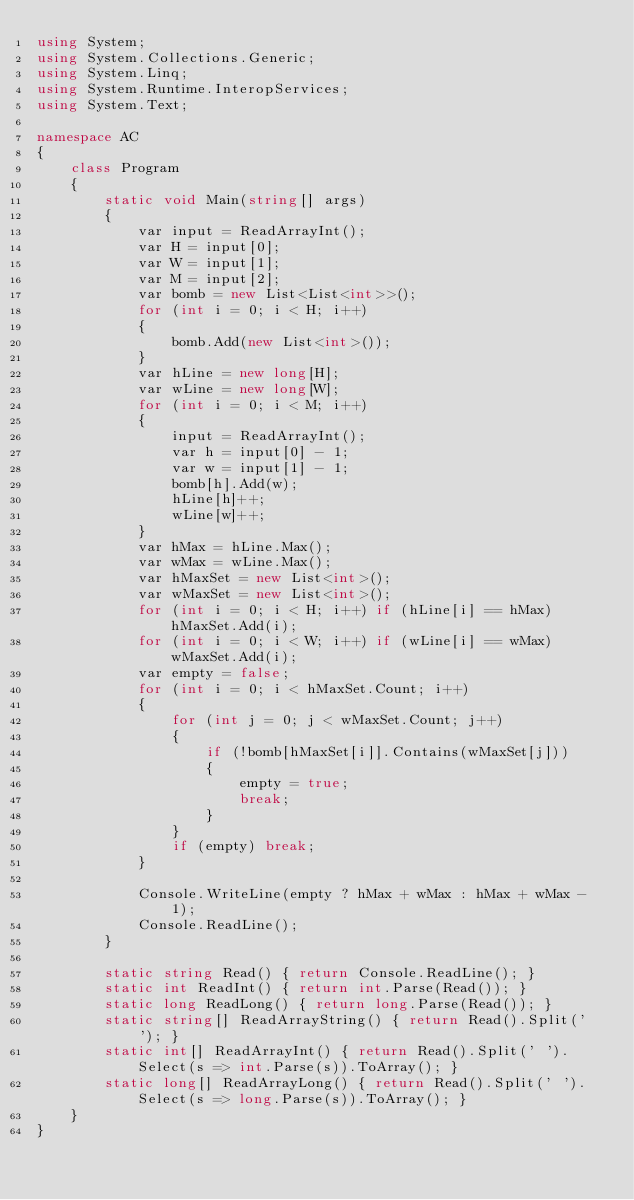<code> <loc_0><loc_0><loc_500><loc_500><_C#_>using System;
using System.Collections.Generic;
using System.Linq;
using System.Runtime.InteropServices;
using System.Text;

namespace AC
{
    class Program
    {
        static void Main(string[] args)
        {
            var input = ReadArrayInt();
            var H = input[0];
            var W = input[1];
            var M = input[2];
            var bomb = new List<List<int>>();
            for (int i = 0; i < H; i++)
            {
                bomb.Add(new List<int>());
            }
            var hLine = new long[H];
            var wLine = new long[W];
            for (int i = 0; i < M; i++)
            {
                input = ReadArrayInt();
                var h = input[0] - 1;
                var w = input[1] - 1;
                bomb[h].Add(w);
                hLine[h]++;
                wLine[w]++;
            }
            var hMax = hLine.Max();
            var wMax = wLine.Max();
            var hMaxSet = new List<int>();
            var wMaxSet = new List<int>();
            for (int i = 0; i < H; i++) if (hLine[i] == hMax) hMaxSet.Add(i);
            for (int i = 0; i < W; i++) if (wLine[i] == wMax) wMaxSet.Add(i);
            var empty = false;
            for (int i = 0; i < hMaxSet.Count; i++)
            {
                for (int j = 0; j < wMaxSet.Count; j++)
                {
                    if (!bomb[hMaxSet[i]].Contains(wMaxSet[j]))
                    {
                        empty = true;
                        break;
                    }
                }
                if (empty) break;
            }

            Console.WriteLine(empty ? hMax + wMax : hMax + wMax - 1);
            Console.ReadLine();
        }

        static string Read() { return Console.ReadLine(); }
        static int ReadInt() { return int.Parse(Read()); }
        static long ReadLong() { return long.Parse(Read()); }
        static string[] ReadArrayString() { return Read().Split(' '); }
        static int[] ReadArrayInt() { return Read().Split(' ').Select(s => int.Parse(s)).ToArray(); }
        static long[] ReadArrayLong() { return Read().Split(' ').Select(s => long.Parse(s)).ToArray(); }
    }
}</code> 